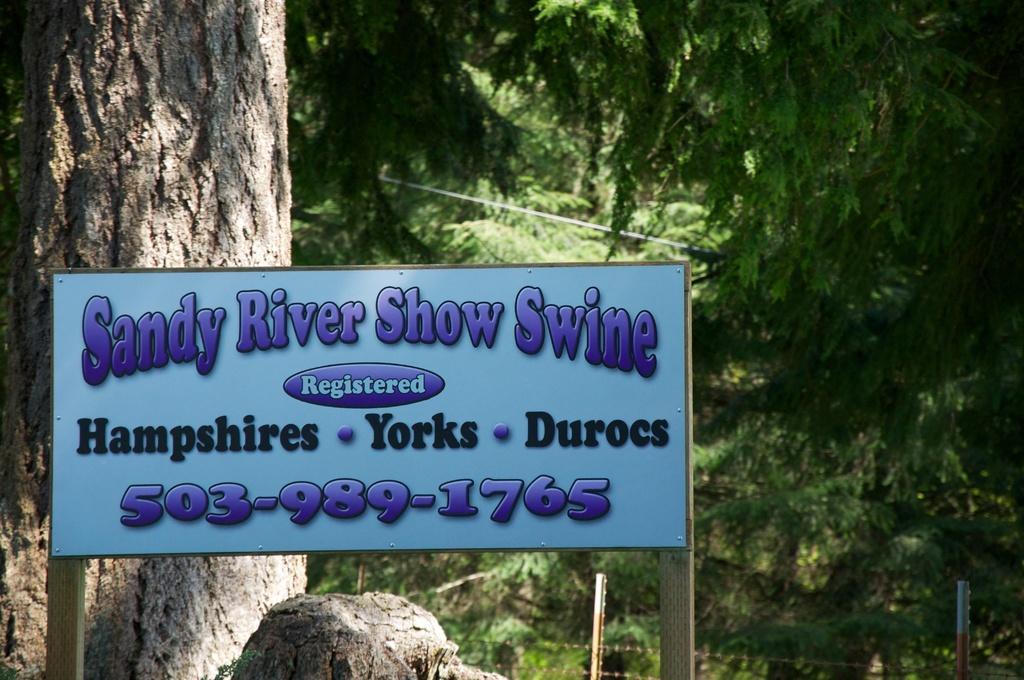Could you give a brief overview of what you see in this image? In the image I can see a board on which there is something written and behind there is a tree trunk, trees and plants. 